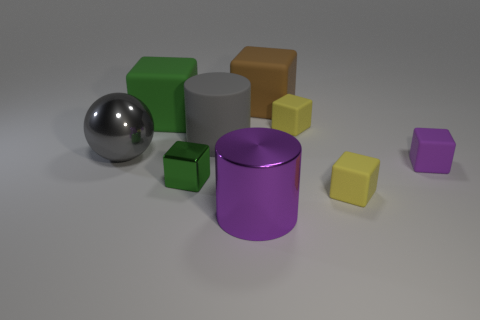The gray cylinder has what size?
Your answer should be very brief. Large. What number of other purple cylinders have the same size as the purple cylinder?
Make the answer very short. 0. There is a rubber cube left of the large purple cylinder; does it have the same size as the metal thing that is to the left of the green metal block?
Keep it short and to the point. Yes. What is the shape of the big thing right of the purple metallic object?
Make the answer very short. Cube. There is a purple thing that is to the right of the large thing that is right of the large purple thing; what is its material?
Offer a very short reply. Rubber. Are there any big metallic objects that have the same color as the large rubber cylinder?
Your answer should be compact. Yes. There is a metal ball; does it have the same size as the green thing that is behind the gray metallic object?
Your response must be concise. Yes. There is a rubber cube behind the green object that is behind the purple rubber cube; what number of large gray objects are to the left of it?
Offer a very short reply. 2. How many matte objects are to the left of the purple matte block?
Offer a very short reply. 5. What is the color of the rubber cube to the left of the matte thing that is behind the green matte cube?
Your answer should be compact. Green. 